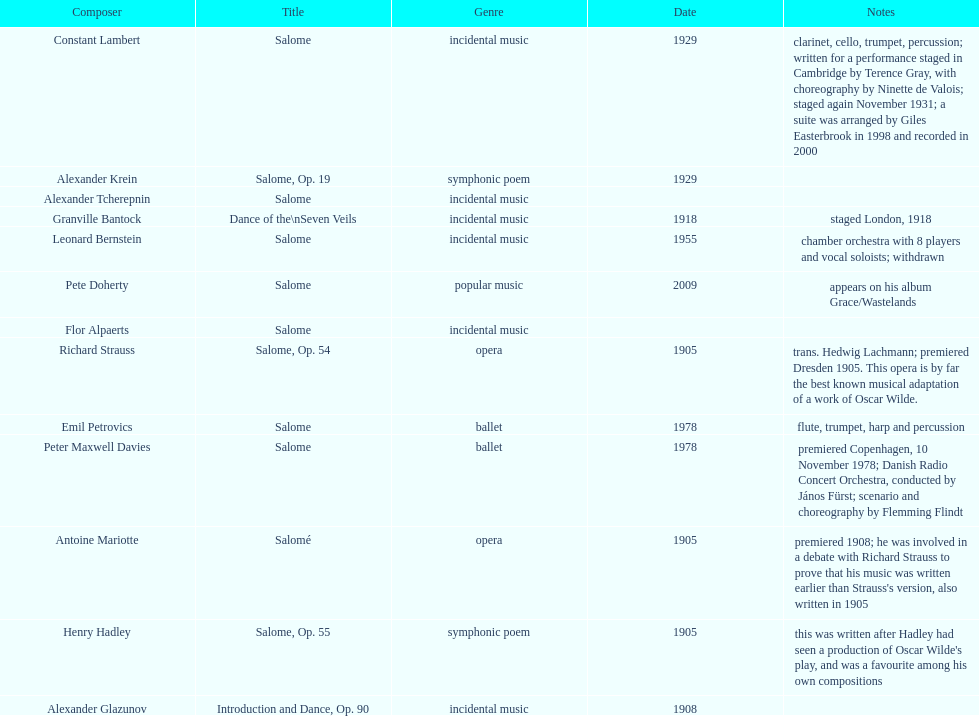Which composer created their work after 2001? Pete Doherty. 